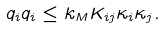Convert formula to latex. <formula><loc_0><loc_0><loc_500><loc_500>q _ { i } q _ { i } \leq k _ { M } K _ { i j } \kappa _ { i } \kappa _ { j } . \</formula> 